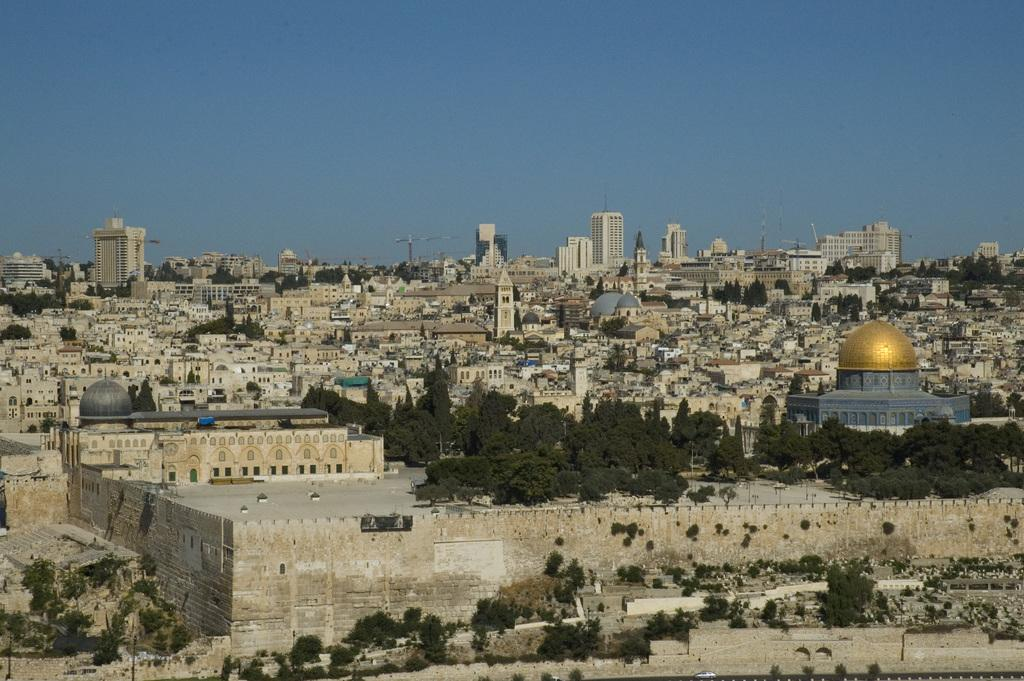What type of structures can be seen in the image? There are many buildings, houses, and towers in the image. What other natural elements are present in the image? There are trees in the image. What can be seen in the background of the image? The sky is visible in the background of the image, and it is clear. What statement is being made by the trees in the image? Trees do not make statements; they are inanimate objects. How are the trees being rubbed in the image? There is no rubbing of trees in the image; the trees are stationary. 